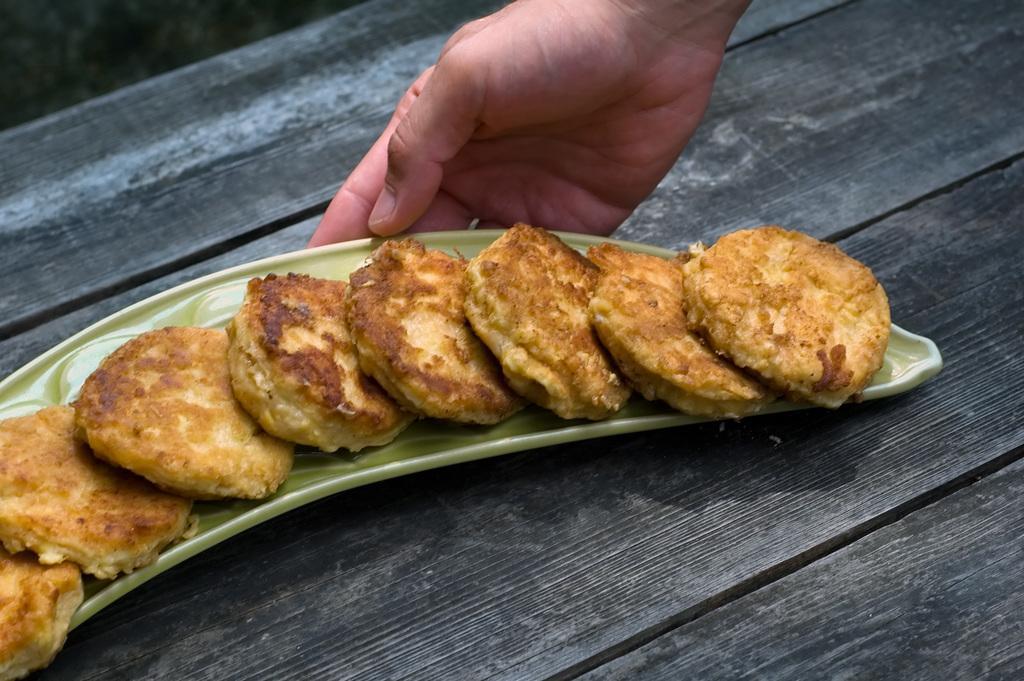Can you describe this image briefly? In this picture we can see some food items in the tray, placed on the wooden table top. Above we can see a person hand. 